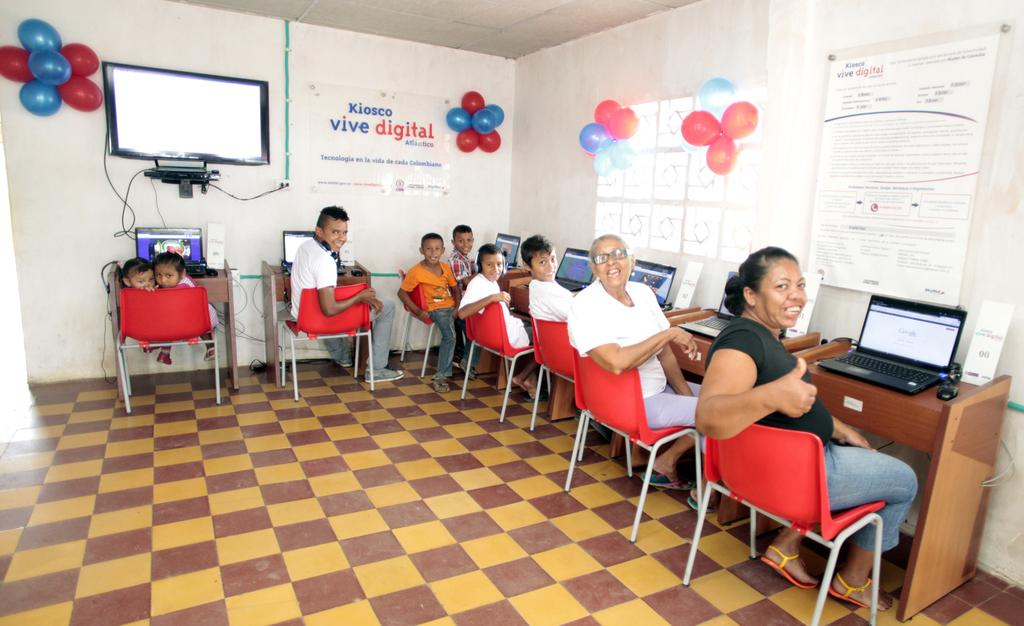What are the people in the image doing? The people in the image are sitting on chairs. What electronic device is on the table? There is a laptop on the table. What is used for controlling the laptop? There is a mouse on the table. What is present at the back side of the image? There is a board and a balloon at the back side of the image. What is the purpose of the screen in the image? The purpose of the screen in the image is not specified, but it could be related to the laptop or the board. What type of popcorn is being served in the image? There is no popcorn present in the image. What type of slave is depicted in the image? There is no depiction of a slave in the image. 